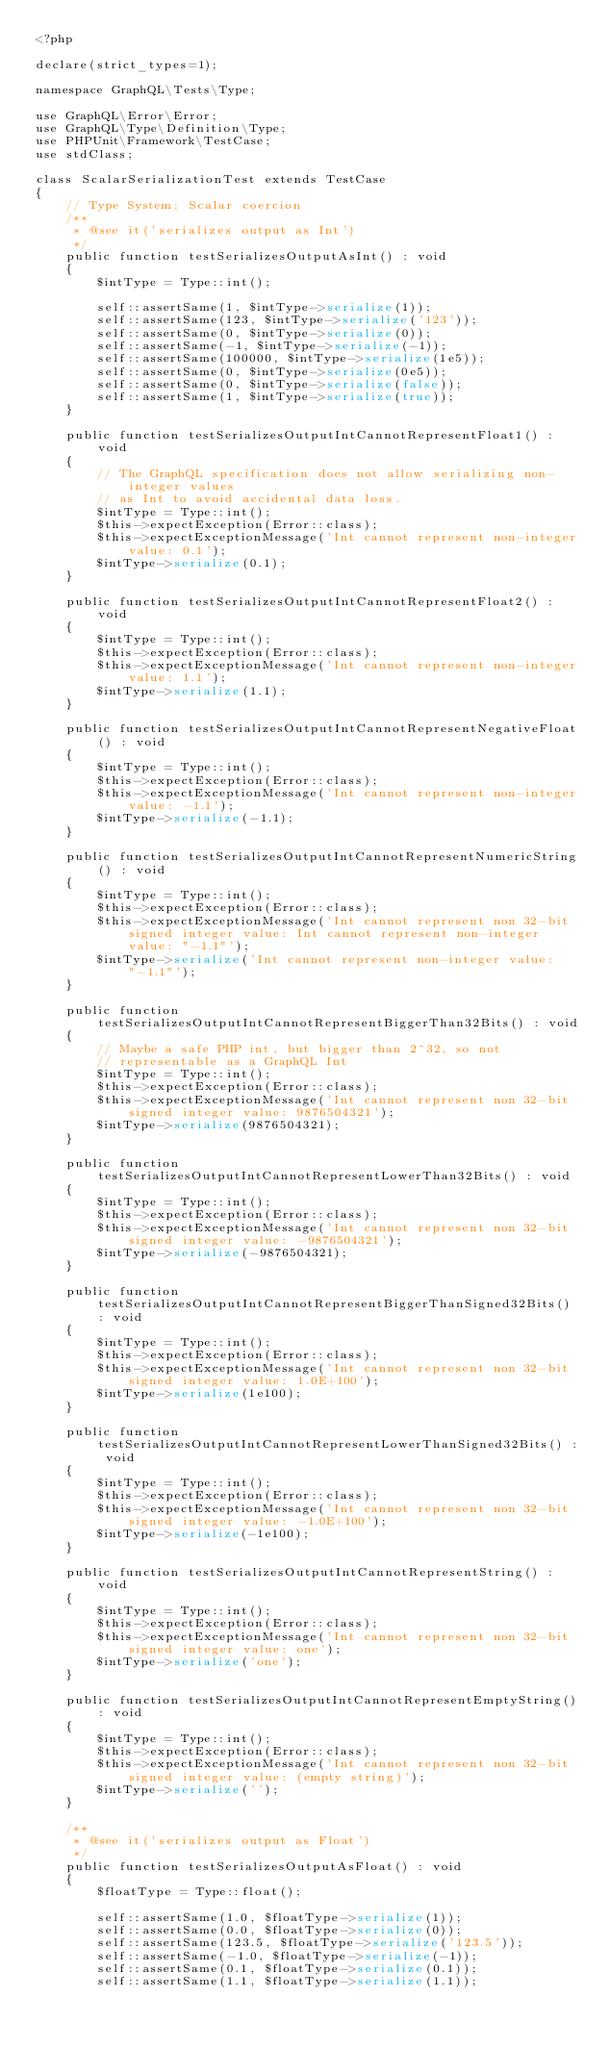<code> <loc_0><loc_0><loc_500><loc_500><_PHP_><?php

declare(strict_types=1);

namespace GraphQL\Tests\Type;

use GraphQL\Error\Error;
use GraphQL\Type\Definition\Type;
use PHPUnit\Framework\TestCase;
use stdClass;

class ScalarSerializationTest extends TestCase
{
    // Type System: Scalar coercion
    /**
     * @see it('serializes output as Int')
     */
    public function testSerializesOutputAsInt() : void
    {
        $intType = Type::int();

        self::assertSame(1, $intType->serialize(1));
        self::assertSame(123, $intType->serialize('123'));
        self::assertSame(0, $intType->serialize(0));
        self::assertSame(-1, $intType->serialize(-1));
        self::assertSame(100000, $intType->serialize(1e5));
        self::assertSame(0, $intType->serialize(0e5));
        self::assertSame(0, $intType->serialize(false));
        self::assertSame(1, $intType->serialize(true));
    }

    public function testSerializesOutputIntCannotRepresentFloat1() : void
    {
        // The GraphQL specification does not allow serializing non-integer values
        // as Int to avoid accidental data loss.
        $intType = Type::int();
        $this->expectException(Error::class);
        $this->expectExceptionMessage('Int cannot represent non-integer value: 0.1');
        $intType->serialize(0.1);
    }

    public function testSerializesOutputIntCannotRepresentFloat2() : void
    {
        $intType = Type::int();
        $this->expectException(Error::class);
        $this->expectExceptionMessage('Int cannot represent non-integer value: 1.1');
        $intType->serialize(1.1);
    }

    public function testSerializesOutputIntCannotRepresentNegativeFloat() : void
    {
        $intType = Type::int();
        $this->expectException(Error::class);
        $this->expectExceptionMessage('Int cannot represent non-integer value: -1.1');
        $intType->serialize(-1.1);
    }

    public function testSerializesOutputIntCannotRepresentNumericString() : void
    {
        $intType = Type::int();
        $this->expectException(Error::class);
        $this->expectExceptionMessage('Int cannot represent non 32-bit signed integer value: Int cannot represent non-integer value: "-1.1"');
        $intType->serialize('Int cannot represent non-integer value: "-1.1"');
    }

    public function testSerializesOutputIntCannotRepresentBiggerThan32Bits() : void
    {
        // Maybe a safe PHP int, but bigger than 2^32, so not
        // representable as a GraphQL Int
        $intType = Type::int();
        $this->expectException(Error::class);
        $this->expectExceptionMessage('Int cannot represent non 32-bit signed integer value: 9876504321');
        $intType->serialize(9876504321);
    }

    public function testSerializesOutputIntCannotRepresentLowerThan32Bits() : void
    {
        $intType = Type::int();
        $this->expectException(Error::class);
        $this->expectExceptionMessage('Int cannot represent non 32-bit signed integer value: -9876504321');
        $intType->serialize(-9876504321);
    }

    public function testSerializesOutputIntCannotRepresentBiggerThanSigned32Bits() : void
    {
        $intType = Type::int();
        $this->expectException(Error::class);
        $this->expectExceptionMessage('Int cannot represent non 32-bit signed integer value: 1.0E+100');
        $intType->serialize(1e100);
    }

    public function testSerializesOutputIntCannotRepresentLowerThanSigned32Bits() : void
    {
        $intType = Type::int();
        $this->expectException(Error::class);
        $this->expectExceptionMessage('Int cannot represent non 32-bit signed integer value: -1.0E+100');
        $intType->serialize(-1e100);
    }

    public function testSerializesOutputIntCannotRepresentString() : void
    {
        $intType = Type::int();
        $this->expectException(Error::class);
        $this->expectExceptionMessage('Int cannot represent non 32-bit signed integer value: one');
        $intType->serialize('one');
    }

    public function testSerializesOutputIntCannotRepresentEmptyString() : void
    {
        $intType = Type::int();
        $this->expectException(Error::class);
        $this->expectExceptionMessage('Int cannot represent non 32-bit signed integer value: (empty string)');
        $intType->serialize('');
    }

    /**
     * @see it('serializes output as Float')
     */
    public function testSerializesOutputAsFloat() : void
    {
        $floatType = Type::float();

        self::assertSame(1.0, $floatType->serialize(1));
        self::assertSame(0.0, $floatType->serialize(0));
        self::assertSame(123.5, $floatType->serialize('123.5'));
        self::assertSame(-1.0, $floatType->serialize(-1));
        self::assertSame(0.1, $floatType->serialize(0.1));
        self::assertSame(1.1, $floatType->serialize(1.1));</code> 